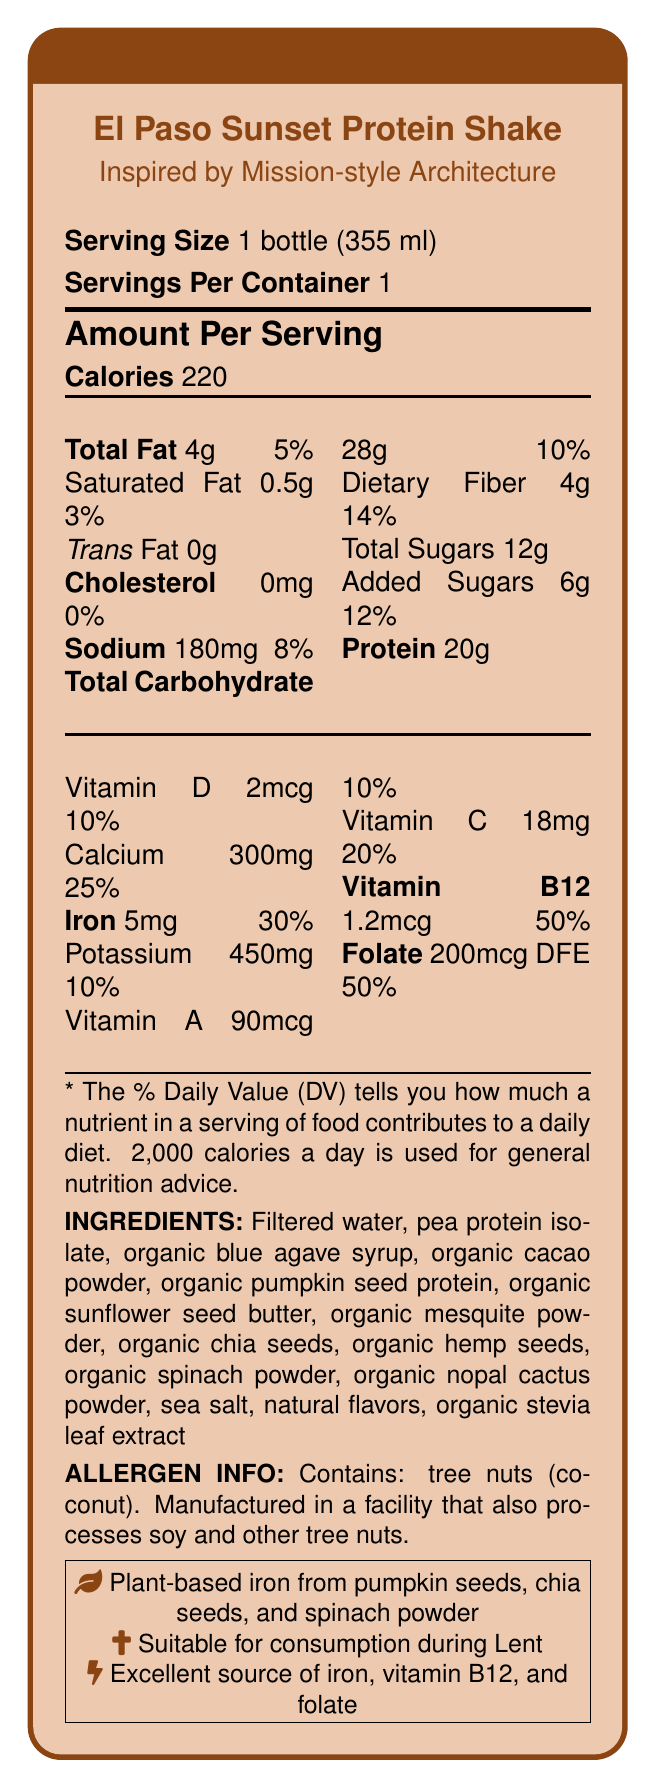What is the serving size of the El Paso Sunset Protein Shake? The serving size is clearly indicated as "1 bottle (355 ml)" in the document.
Answer: 1 bottle (355 ml) How many grams of total fat does the shake contain? Under the "Total Fat" section, the amount is listed as 4g.
Answer: 4g What percentage of the Daily Value for iron is provided by the El Paso Sunset Protein Shake? The document states that the iron content is 5mg, which is 30% of the Daily Value.
Answer: 30% Which plant-based ingredients are sources of iron in this shake? The document specifies plant-based iron sources as pumpkin seeds, chia seeds, and spinach powder.
Answer: Pumpkin seeds, chia seeds, and spinach powder Is the El Paso Sunset Protein Shake suitable for consumption during Lent? The document includes a note stating that the shake is suitable for consumption during Lent.
Answer: Yes How many calories are there in one serving of the El Paso Sunset Protein Shake? The number of calories per serving is explicitly listed as 220.
Answer: 220 Which vitamins are notably highlighted for their health benefits? The document specifically highlights iron, vitamin B12, and folate as key nutrients supporting health.
Answer: Iron, vitamin B12, and folate What is the architectural inspiration for the shake's bottle design? The document mentions that the bottle design is inspired by the Mission-style architecture of El Paso.
Answer: Mission-style architecture of El Paso What is the amount of calcium in one serving of the shake? The document lists calcium as having an amount of 300mg per serving.
Answer: 300mg How much protein does one bottle contain? The document states that the shake contains 20g of protein per serving.
Answer: 20g What is the source of sweetness in the shake? The ingredient list includes "organic blue agave syrup" as a source of sweetness.
Answer: Organic blue agave syrup How many grams of dietary fiber does the shake contain per serving? The amount of dietary fiber per serving is listed as 4g.
Answer: 4g What kind of fats are not present in the El Paso Sunset Protein Shake? A. Trans fat B. Saturated fat C. Total fat D. Cholesterol According to the document, the shake contains 0g of trans fat.
Answer: A. Trans fat Which vitamin has the highest percentage of the Daily Value per serving in the shake? A. Vitamin D B. Calcium C. Iron D. Vitamin B12 The document indicates that vitamin B12 has the highest Daily Value percentage at 50%.
Answer: D. Vitamin B12 Does the shake contain any added sugars? The document specifies that there are 6g of added sugars, which account for 12% of the Daily Value.
Answer: Yes Summarize the main features and nutritional content of the El Paso Sunset Protein Shake. The summary includes key points about the shake's inspiration, nutritional content, and suitability for different dietary restrictions.
Answer: The El Paso Sunset Protein Shake is a Southwestern-inspired vegetarian protein shake with a Mission-style architecture bottle design. Each 355 ml bottle contains 220 calories, 4g of total fat, and 20g of protein. It is rich in iron (30% DV), vitamin B12 (50% DV), and folate (50% DV). The shake also has substantial amounts of calcium, potassium, and vitamins A, C, and D. It contains plant-based ingredients like pumpkin seeds, chia seeds, and spinach powder, and is suitable for consumption during Lent. Can the El Paso Sunset Protein Shake be used as a meal replacement for weight loss? The document does not provide information on whether the shake can be used as a meal replacement for weight loss.
Answer: Cannot be determined 